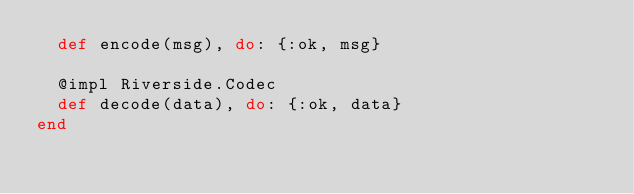<code> <loc_0><loc_0><loc_500><loc_500><_Elixir_>  def encode(msg), do: {:ok, msg}

  @impl Riverside.Codec
  def decode(data), do: {:ok, data}
end
</code> 